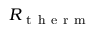<formula> <loc_0><loc_0><loc_500><loc_500>R _ { t h e r m }</formula> 